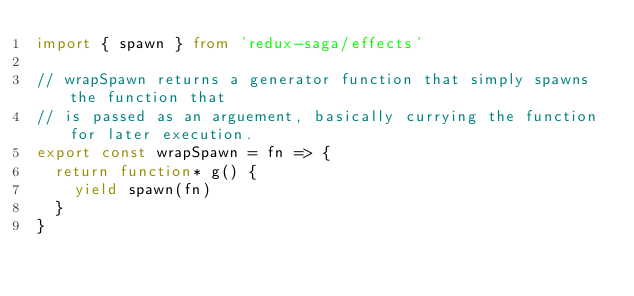<code> <loc_0><loc_0><loc_500><loc_500><_TypeScript_>import { spawn } from 'redux-saga/effects'

// wrapSpawn returns a generator function that simply spawns the function that
// is passed as an arguement, basically currying the function for later execution.
export const wrapSpawn = fn => {
  return function* g() {
    yield spawn(fn)
  }
}
</code> 